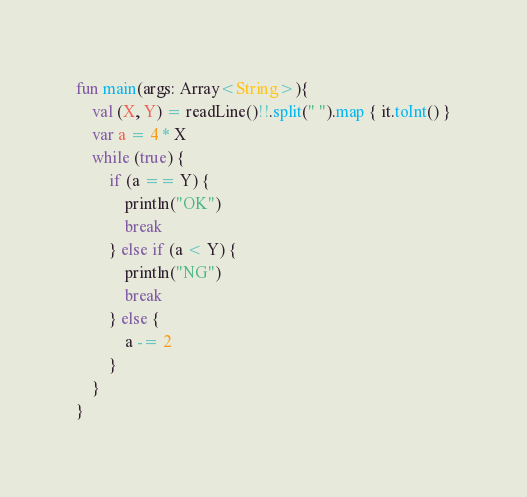<code> <loc_0><loc_0><loc_500><loc_500><_Kotlin_>fun main(args: Array<String>){
    val (X, Y) = readLine()!!.split(" ").map { it.toInt() }
    var a = 4 * X
    while (true) {
        if (a == Y) {
            println("OK")
            break
        } else if (a < Y) {
            println("NG")
            break
        } else {
            a -= 2
        }
    }
}


</code> 